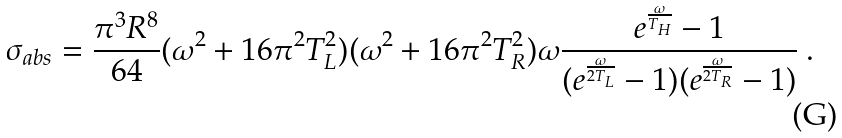<formula> <loc_0><loc_0><loc_500><loc_500>\sigma _ { a b s } = { \frac { \pi ^ { 3 } R ^ { 8 } } { 6 4 } } ( \omega ^ { 2 } + 1 6 \pi ^ { 2 } T _ { L } ^ { 2 } ) ( \omega ^ { 2 } + 1 6 \pi ^ { 2 } T _ { R } ^ { 2 } ) \omega { \frac { e ^ { \frac { \omega } { T _ { H } } } - 1 } { ( e ^ { \frac { \omega } { 2 T _ { L } } } - 1 ) ( e ^ { \frac { \omega } { 2 T _ { R } } } - 1 ) } } \ .</formula> 